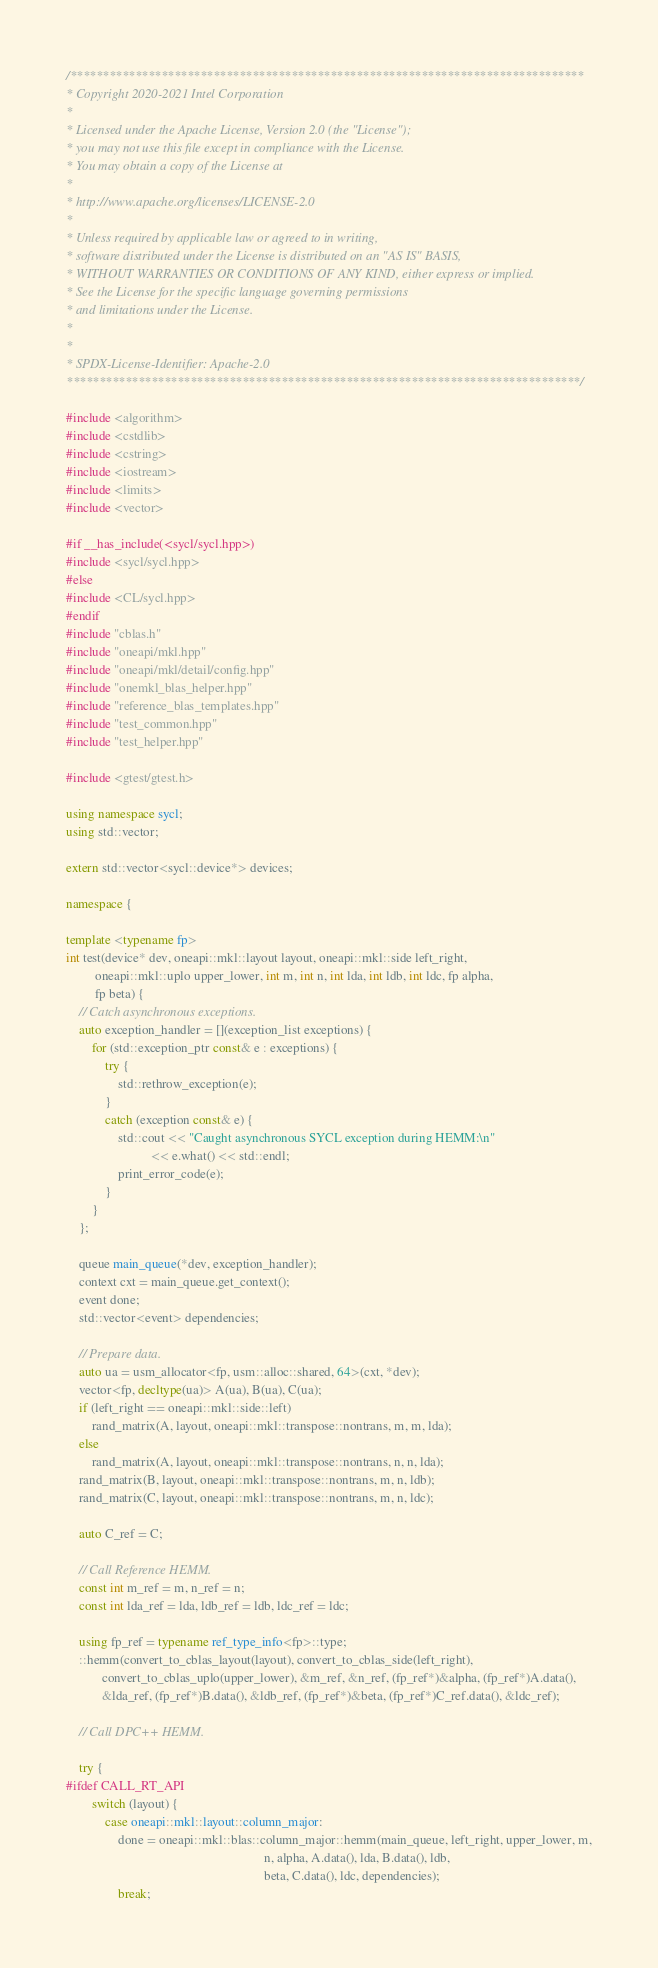<code> <loc_0><loc_0><loc_500><loc_500><_C++_>/*******************************************************************************
* Copyright 2020-2021 Intel Corporation
*
* Licensed under the Apache License, Version 2.0 (the "License");
* you may not use this file except in compliance with the License.
* You may obtain a copy of the License at
*
* http://www.apache.org/licenses/LICENSE-2.0
*
* Unless required by applicable law or agreed to in writing,
* software distributed under the License is distributed on an "AS IS" BASIS,
* WITHOUT WARRANTIES OR CONDITIONS OF ANY KIND, either express or implied.
* See the License for the specific language governing permissions
* and limitations under the License.
*
*
* SPDX-License-Identifier: Apache-2.0
*******************************************************************************/

#include <algorithm>
#include <cstdlib>
#include <cstring>
#include <iostream>
#include <limits>
#include <vector>

#if __has_include(<sycl/sycl.hpp>)
#include <sycl/sycl.hpp>
#else
#include <CL/sycl.hpp>
#endif
#include "cblas.h"
#include "oneapi/mkl.hpp"
#include "oneapi/mkl/detail/config.hpp"
#include "onemkl_blas_helper.hpp"
#include "reference_blas_templates.hpp"
#include "test_common.hpp"
#include "test_helper.hpp"

#include <gtest/gtest.h>

using namespace sycl;
using std::vector;

extern std::vector<sycl::device*> devices;

namespace {

template <typename fp>
int test(device* dev, oneapi::mkl::layout layout, oneapi::mkl::side left_right,
         oneapi::mkl::uplo upper_lower, int m, int n, int lda, int ldb, int ldc, fp alpha,
         fp beta) {
    // Catch asynchronous exceptions.
    auto exception_handler = [](exception_list exceptions) {
        for (std::exception_ptr const& e : exceptions) {
            try {
                std::rethrow_exception(e);
            }
            catch (exception const& e) {
                std::cout << "Caught asynchronous SYCL exception during HEMM:\n"
                          << e.what() << std::endl;
                print_error_code(e);
            }
        }
    };

    queue main_queue(*dev, exception_handler);
    context cxt = main_queue.get_context();
    event done;
    std::vector<event> dependencies;

    // Prepare data.
    auto ua = usm_allocator<fp, usm::alloc::shared, 64>(cxt, *dev);
    vector<fp, decltype(ua)> A(ua), B(ua), C(ua);
    if (left_right == oneapi::mkl::side::left)
        rand_matrix(A, layout, oneapi::mkl::transpose::nontrans, m, m, lda);
    else
        rand_matrix(A, layout, oneapi::mkl::transpose::nontrans, n, n, lda);
    rand_matrix(B, layout, oneapi::mkl::transpose::nontrans, m, n, ldb);
    rand_matrix(C, layout, oneapi::mkl::transpose::nontrans, m, n, ldc);

    auto C_ref = C;

    // Call Reference HEMM.
    const int m_ref = m, n_ref = n;
    const int lda_ref = lda, ldb_ref = ldb, ldc_ref = ldc;

    using fp_ref = typename ref_type_info<fp>::type;
    ::hemm(convert_to_cblas_layout(layout), convert_to_cblas_side(left_right),
           convert_to_cblas_uplo(upper_lower), &m_ref, &n_ref, (fp_ref*)&alpha, (fp_ref*)A.data(),
           &lda_ref, (fp_ref*)B.data(), &ldb_ref, (fp_ref*)&beta, (fp_ref*)C_ref.data(), &ldc_ref);

    // Call DPC++ HEMM.

    try {
#ifdef CALL_RT_API
        switch (layout) {
            case oneapi::mkl::layout::column_major:
                done = oneapi::mkl::blas::column_major::hemm(main_queue, left_right, upper_lower, m,
                                                             n, alpha, A.data(), lda, B.data(), ldb,
                                                             beta, C.data(), ldc, dependencies);
                break;</code> 